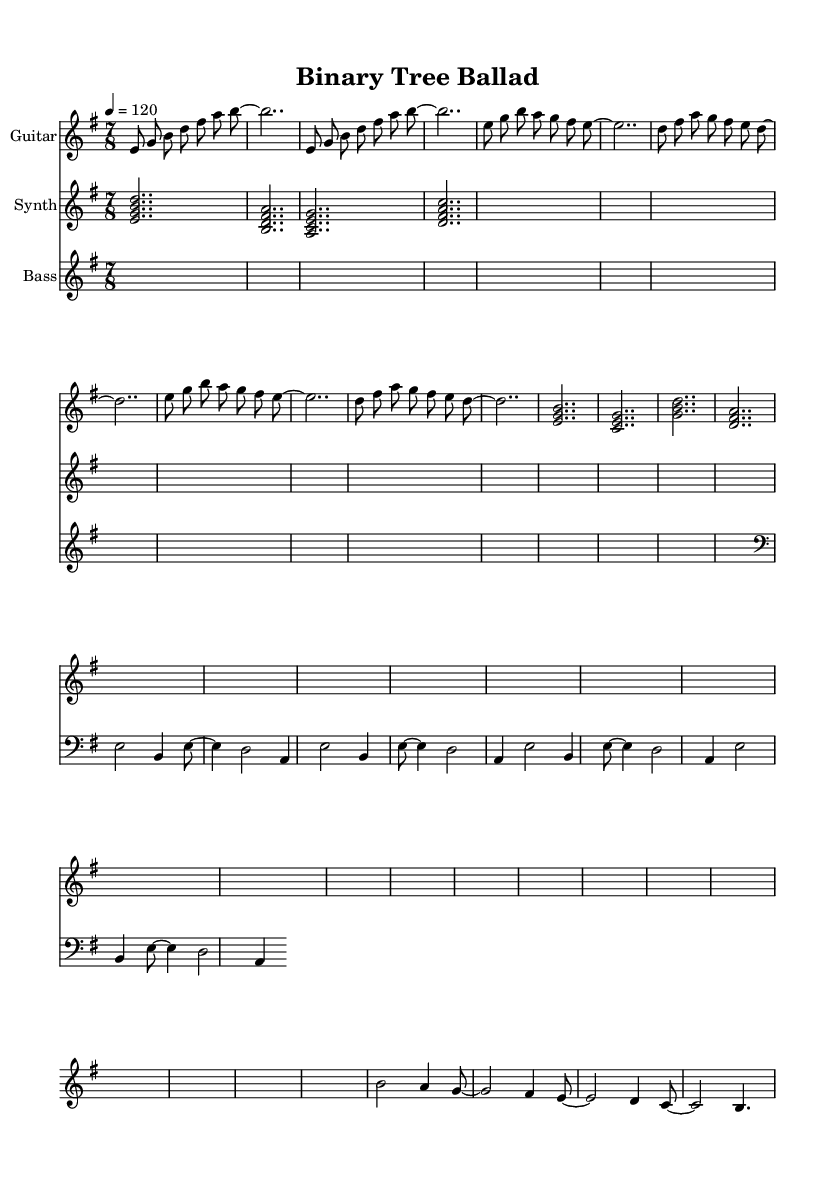What is the key signature of this music? The key signature is E minor, which has one sharp (F#). This is determined by looking at the key signature indicated at the beginning of the score.
Answer: E minor What is the time signature of the piece? The time signature is 7/8, which means there are seven eighth notes in each measure. This can be seen at the beginning of the music, next to the key signature.
Answer: 7/8 What is the tempo marking for the piece? The tempo marking indicates a speed of 120 beats per minute, shown as "4 = 120" at the beginning of the score. This means that there are four quarter note beats in a minute.
Answer: 120 How many times does the guitar intro repeat? The guitar intro section is marked with " \repeat unfold 2", indicating that it should be played two times in total. This information is in the guitarIntro section of the code.
Answer: 2 What is the main theme explored in the lyrics of this Progressive rock piece? The lyrics focus on data structures and algorithms, which is a common theme in progressive rock. This can be inferred from the title "Binary Tree Ballad" and the musical motifs that represent such concepts.
Answer: Data structures What is the instrumentation used in this piece? The score includes three instruments: Guitar, Synth, and Bass, as indicated by the instrument names specified in the score sections.
Answer: Guitar, Synth, Bass Which section of the score has a higher pitch overall, Guitar or Synth? The Synth section generally plays in a higher octave compared to the Guitar. By examining the range of notes in both sections, it's clear that the Synth plays notes such as <e g b d>, which are higher than the Guitar's lowest notes.
Answer: Synth 